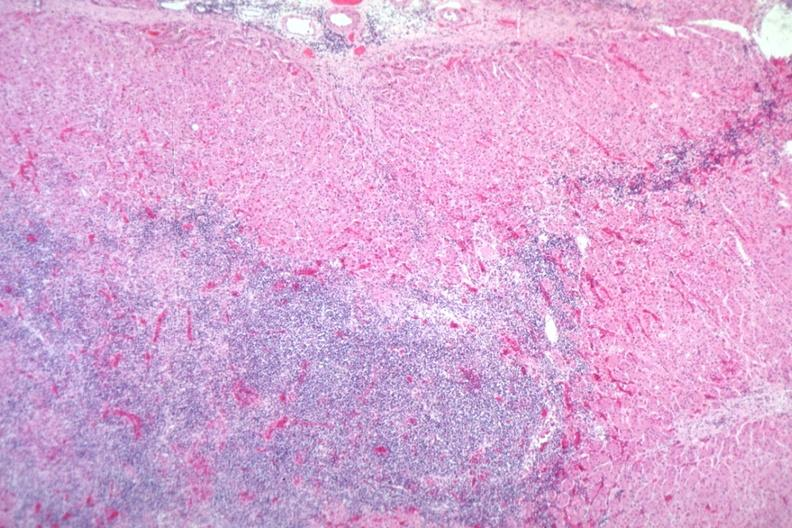s adenocarcinoma present?
Answer the question using a single word or phrase. No 